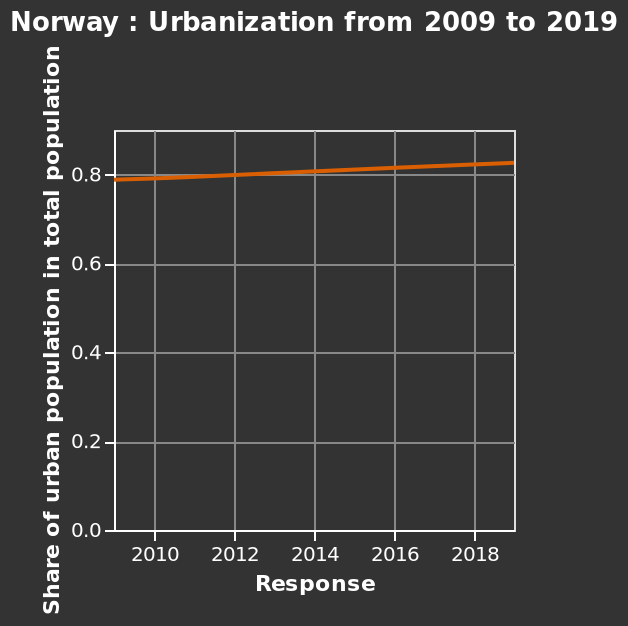<image>
What does the x-axis measure in the line plot? The x-axis measures "Response" in the line plot. 